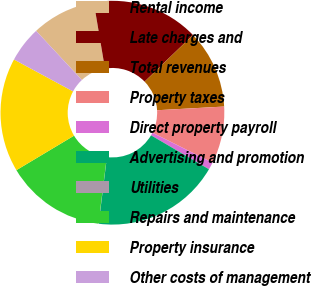<chart> <loc_0><loc_0><loc_500><loc_500><pie_chart><fcel>Rental income<fcel>Late charges and<fcel>Total revenues<fcel>Property taxes<fcel>Direct property payroll<fcel>Advertising and promotion<fcel>Utilities<fcel>Repairs and maintenance<fcel>Property insurance<fcel>Other costs of management<nl><fcel>9.28%<fcel>15.45%<fcel>11.34%<fcel>8.25%<fcel>1.06%<fcel>18.53%<fcel>0.03%<fcel>14.42%<fcel>16.47%<fcel>5.17%<nl></chart> 